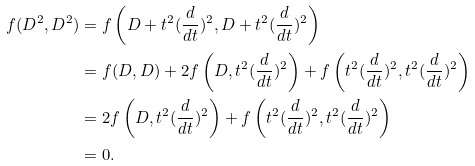<formula> <loc_0><loc_0><loc_500><loc_500>f ( D ^ { 2 } , D ^ { 2 } ) & = f \left ( D + t ^ { 2 } ( \frac { d } { d t } ) ^ { 2 } , D + t ^ { 2 } ( \frac { d } { d t } ) ^ { 2 } \right ) \\ & = f ( D , D ) + 2 f \left ( D , t ^ { 2 } ( \frac { d } { d t } ) ^ { 2 } \right ) + f \left ( t ^ { 2 } ( \frac { d } { d t } ) ^ { 2 } , t ^ { 2 } ( \frac { d } { d t } ) ^ { 2 } \right ) \\ & = 2 f \left ( D , t ^ { 2 } ( \frac { d } { d t } ) ^ { 2 } \right ) + f \left ( t ^ { 2 } ( \frac { d } { d t } ) ^ { 2 } , t ^ { 2 } ( \frac { d } { d t } ) ^ { 2 } \right ) \\ & = 0 .</formula> 